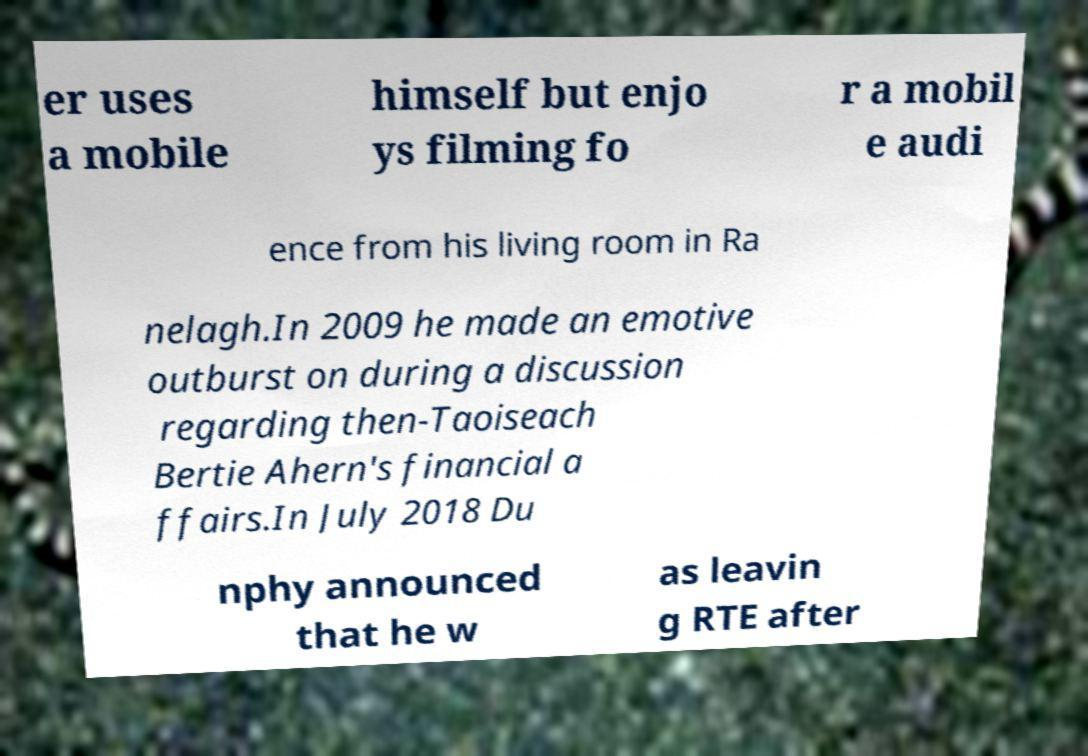I need the written content from this picture converted into text. Can you do that? er uses a mobile himself but enjo ys filming fo r a mobil e audi ence from his living room in Ra nelagh.In 2009 he made an emotive outburst on during a discussion regarding then-Taoiseach Bertie Ahern's financial a ffairs.In July 2018 Du nphy announced that he w as leavin g RTE after 